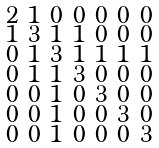Convert formula to latex. <formula><loc_0><loc_0><loc_500><loc_500>\begin{smallmatrix} 2 & 1 & 0 & 0 & 0 & 0 & 0 \\ 1 & 3 & 1 & 1 & 0 & 0 & 0 \\ 0 & 1 & 3 & 1 & 1 & 1 & 1 \\ 0 & 1 & 1 & 3 & 0 & 0 & 0 \\ 0 & 0 & 1 & 0 & 3 & 0 & 0 \\ 0 & 0 & 1 & 0 & 0 & 3 & 0 \\ 0 & 0 & 1 & 0 & 0 & 0 & 3 \end{smallmatrix}</formula> 